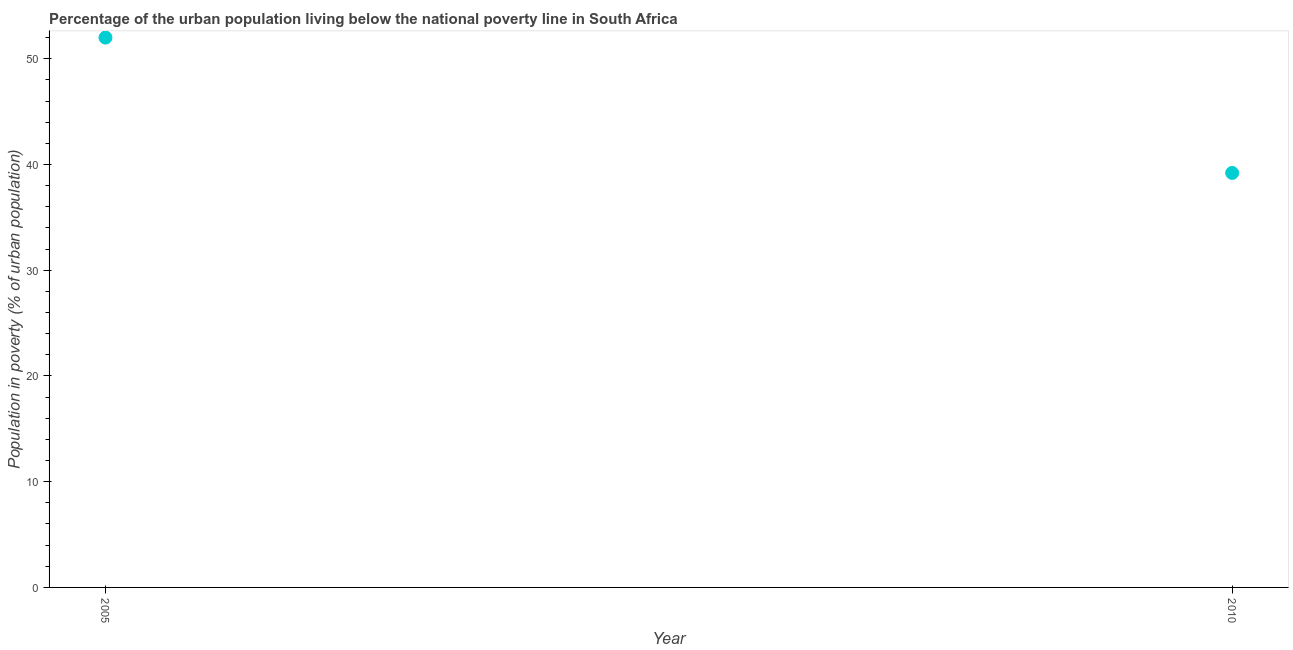What is the percentage of urban population living below poverty line in 2010?
Your response must be concise. 39.2. Across all years, what is the maximum percentage of urban population living below poverty line?
Make the answer very short. 52. Across all years, what is the minimum percentage of urban population living below poverty line?
Your answer should be compact. 39.2. In which year was the percentage of urban population living below poverty line maximum?
Your answer should be very brief. 2005. In which year was the percentage of urban population living below poverty line minimum?
Keep it short and to the point. 2010. What is the sum of the percentage of urban population living below poverty line?
Provide a short and direct response. 91.2. What is the difference between the percentage of urban population living below poverty line in 2005 and 2010?
Give a very brief answer. 12.8. What is the average percentage of urban population living below poverty line per year?
Keep it short and to the point. 45.6. What is the median percentage of urban population living below poverty line?
Your answer should be very brief. 45.6. In how many years, is the percentage of urban population living below poverty line greater than 10 %?
Your answer should be very brief. 2. What is the ratio of the percentage of urban population living below poverty line in 2005 to that in 2010?
Offer a terse response. 1.33. In how many years, is the percentage of urban population living below poverty line greater than the average percentage of urban population living below poverty line taken over all years?
Your response must be concise. 1. How many dotlines are there?
Give a very brief answer. 1. Are the values on the major ticks of Y-axis written in scientific E-notation?
Give a very brief answer. No. Does the graph contain any zero values?
Your answer should be compact. No. Does the graph contain grids?
Your response must be concise. No. What is the title of the graph?
Provide a succinct answer. Percentage of the urban population living below the national poverty line in South Africa. What is the label or title of the Y-axis?
Your answer should be compact. Population in poverty (% of urban population). What is the Population in poverty (% of urban population) in 2005?
Your answer should be compact. 52. What is the Population in poverty (% of urban population) in 2010?
Ensure brevity in your answer.  39.2. What is the ratio of the Population in poverty (% of urban population) in 2005 to that in 2010?
Give a very brief answer. 1.33. 